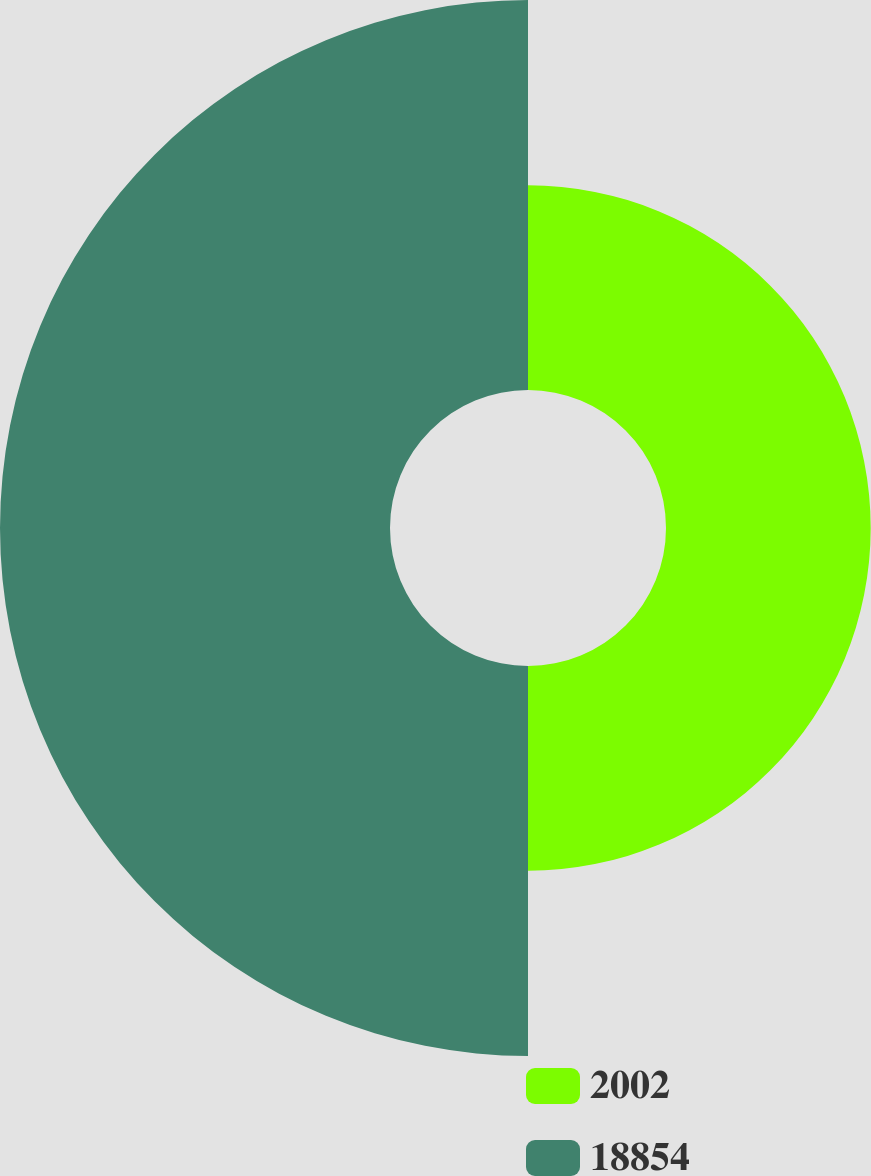<chart> <loc_0><loc_0><loc_500><loc_500><pie_chart><fcel>2002<fcel>18854<nl><fcel>34.42%<fcel>65.58%<nl></chart> 